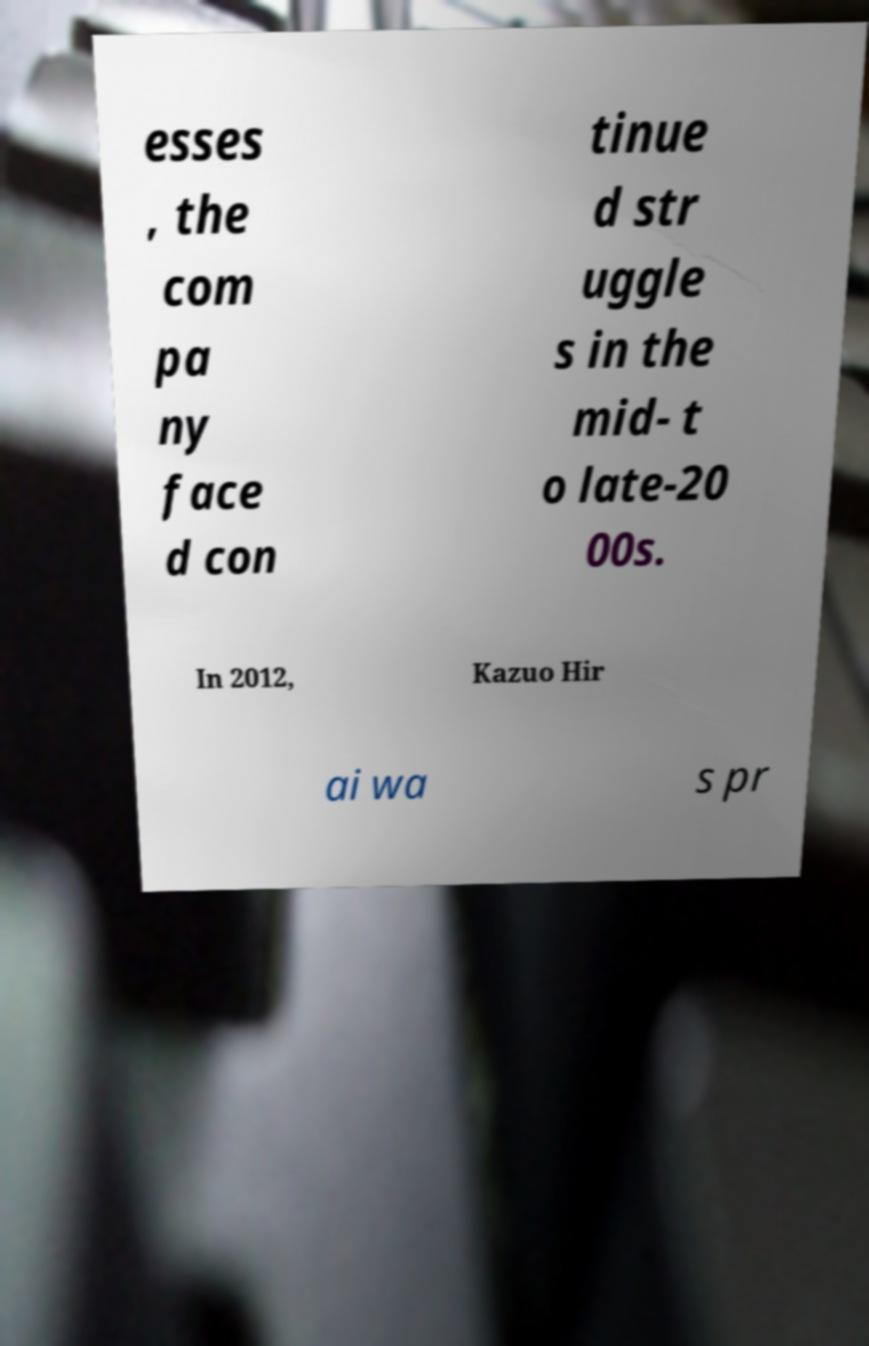For documentation purposes, I need the text within this image transcribed. Could you provide that? esses , the com pa ny face d con tinue d str uggle s in the mid- t o late-20 00s. In 2012, Kazuo Hir ai wa s pr 